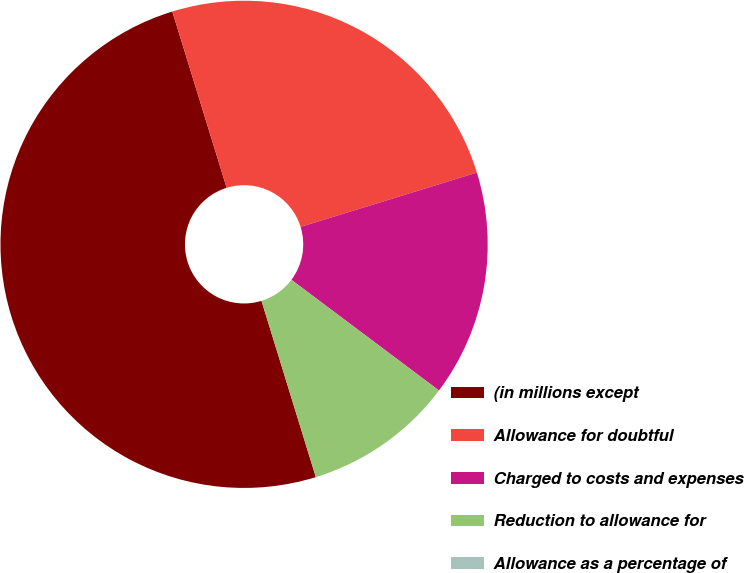Convert chart. <chart><loc_0><loc_0><loc_500><loc_500><pie_chart><fcel>(in millions except<fcel>Allowance for doubtful<fcel>Charged to costs and expenses<fcel>Reduction to allowance for<fcel>Allowance as a percentage of<nl><fcel>50.0%<fcel>25.0%<fcel>15.0%<fcel>10.0%<fcel>0.0%<nl></chart> 